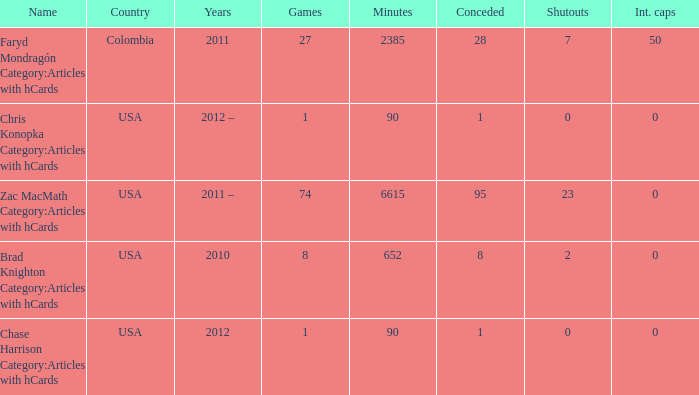Could you parse the entire table as a dict? {'header': ['Name', 'Country', 'Years', 'Games', 'Minutes', 'Conceded', 'Shutouts', 'Int. caps'], 'rows': [['Faryd Mondragón Category:Articles with hCards', 'Colombia', '2011', '27', '2385', '28', '7', '50'], ['Chris Konopka Category:Articles with hCards', 'USA', '2012 –', '1', '90', '1', '0', '0'], ['Zac MacMath Category:Articles with hCards', 'USA', '2011 –', '74', '6615', '95', '23', '0'], ['Brad Knighton Category:Articles with hCards', 'USA', '2010', '8', '652', '8', '2', '0'], ['Chase Harrison Category:Articles with hCards', 'USA', '2012', '1', '90', '1', '0', '0']]} When chase harrison category:articles with hcards is the name what is the year? 2012.0. 